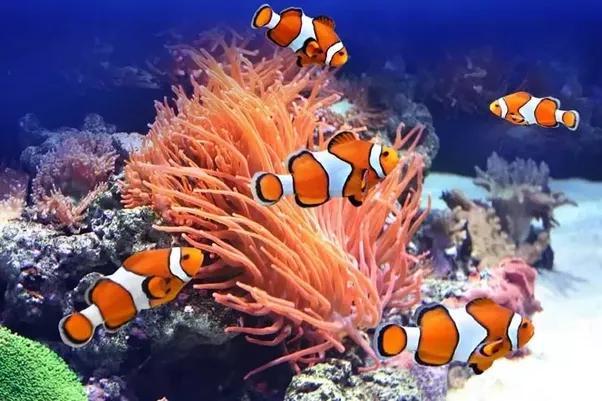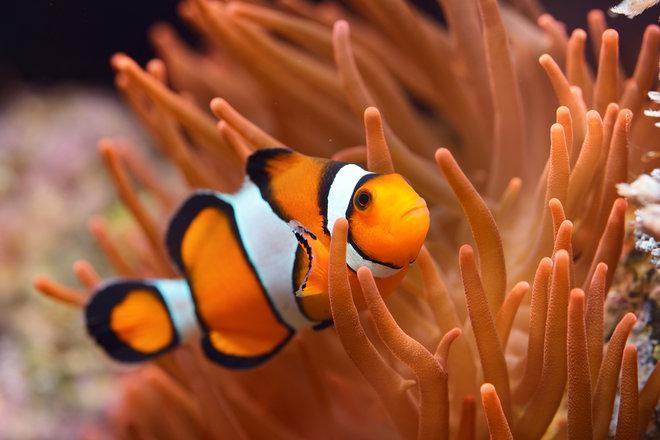The first image is the image on the left, the second image is the image on the right. Assess this claim about the two images: "The left image features exactly two clown fish swimming in anemone tendrils, and the right image features one fish swimming in a different color of anemone tendrils.". Correct or not? Answer yes or no. No. The first image is the image on the left, the second image is the image on the right. Examine the images to the left and right. Is the description "Exactly two clown-fish are interacting with an anemone in the left photo while exactly one fish is within the orange colored anemone in the right photo." accurate? Answer yes or no. No. 